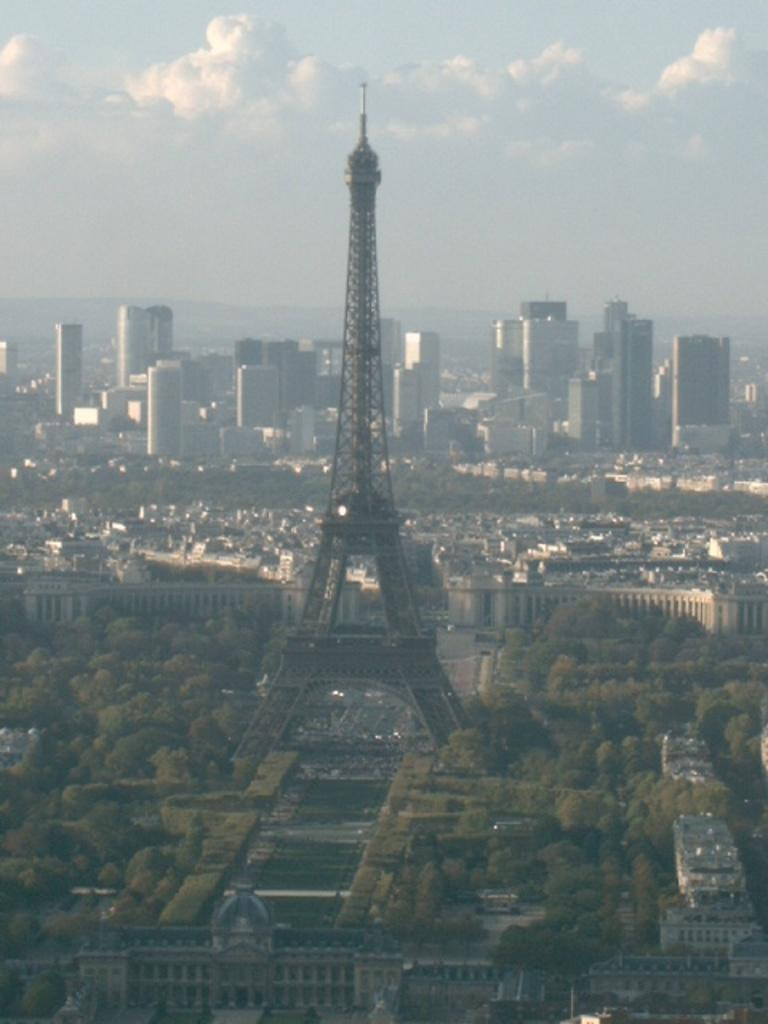What type of natural feature can be seen in the image? There is a group of trees in the image. What type of man-made structures are present in the image? There are buildings in the image. What famous landmark is in the center of the image? The Eiffel Tower is in the center of the image. What part of the natural environment is visible in the image? The sky is visible at the top of the image. What is the weather like in the image? The sky appears to be cloudy in the image. What time does the clock on the Eiffel Tower show in the image? There is no clock present on the Eiffel Tower in the image. What advice would the grandmother give to the group of trees in the image? There is no grandmother present in the image, and trees do not receive advice. 